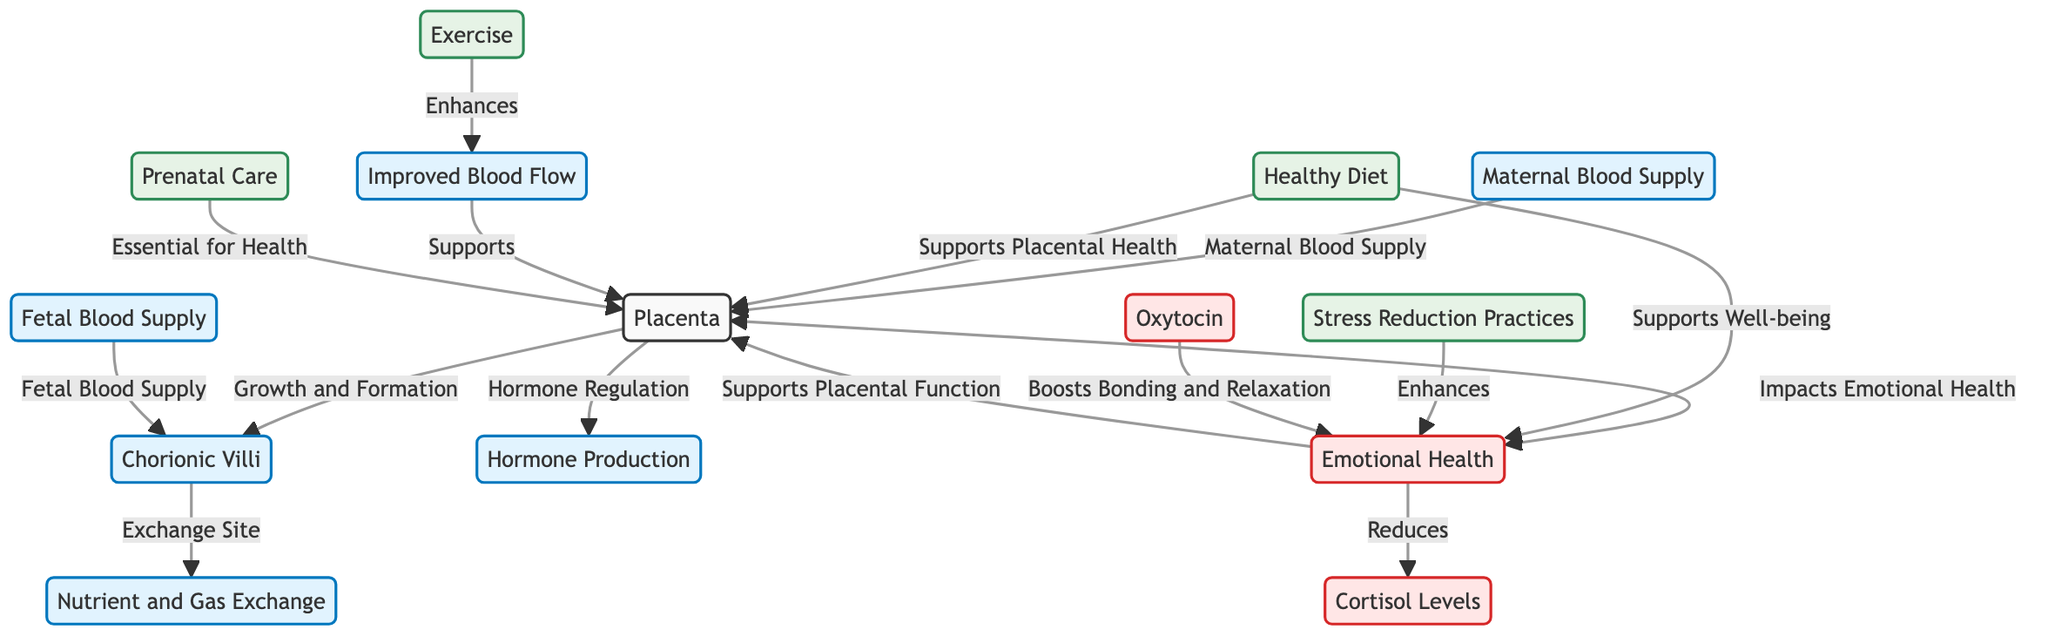What is the role of chorionic villi in the placenta? The diagram identifies chorionic villi as the exchange site for nutrient and gas exchange between maternal and fetal blood supplies, indicating their critical role in the placenta's function.
Answer: Exchange Site What does maternal blood supply provide to the placenta? The diagram specifies that the maternal blood supply brings essential nutrients and oxygen to support placental growth and function.
Answer: Nutrients and Oxygen How does stress reduction affect emotional health? According to the diagram, stress reduction practices enhance emotional health, showing a direct positive relationship between the two nodes in the diagram.
Answer: Enhances What is the connection between emotional health and cortisol levels? The diagram illustrates that emotional health reduces cortisol levels, indicating that improved emotional well-being can lead to lower stress hormone levels.
Answer: Reduces How many support elements are identified for placental health? The diagram shows three nodes related to support: Healthy Diet, Exercise, and Prenatal Care, clearly indicating the number of supportive elements for placental health.
Answer: Three What enhances blood flow to the placenta? The diagram indicates that exercise enhances blood flow, which in turn supports placental function, establishing a clear relationship between these two processes.
Answer: Exercise What hormones are mentioned in relation to emotional health? The diagram lists oxytocin as a hormone that boosts bonding and relaxation, highlighting its role in emotional health along with cortisol.
Answer: Oxytocin Which node is impacted by both diet and emotional health? The diagram suggests that both diet and emotional health directly support placental function, showing their intertwined relationship with placental health.
Answer: Placenta What is the main purpose of prenatal care in this diagram? The diagram identifies prenatal care as essential for health, linking it directly to the placental function, emphasizing its significance.
Answer: Essential for Health 